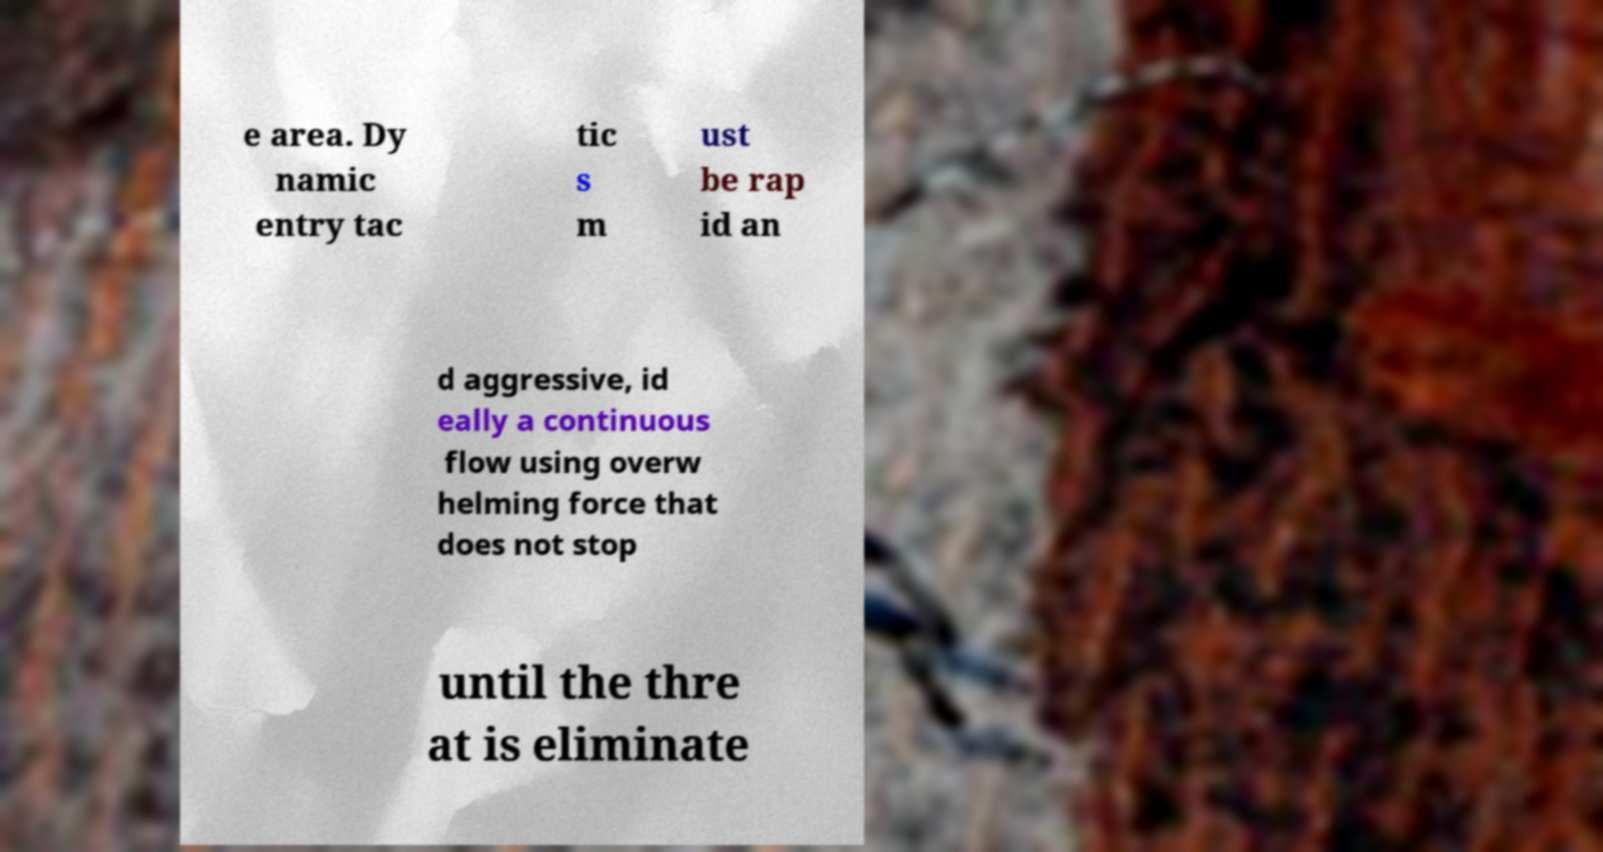Could you assist in decoding the text presented in this image and type it out clearly? e area. Dy namic entry tac tic s m ust be rap id an d aggressive, id eally a continuous flow using overw helming force that does not stop until the thre at is eliminate 